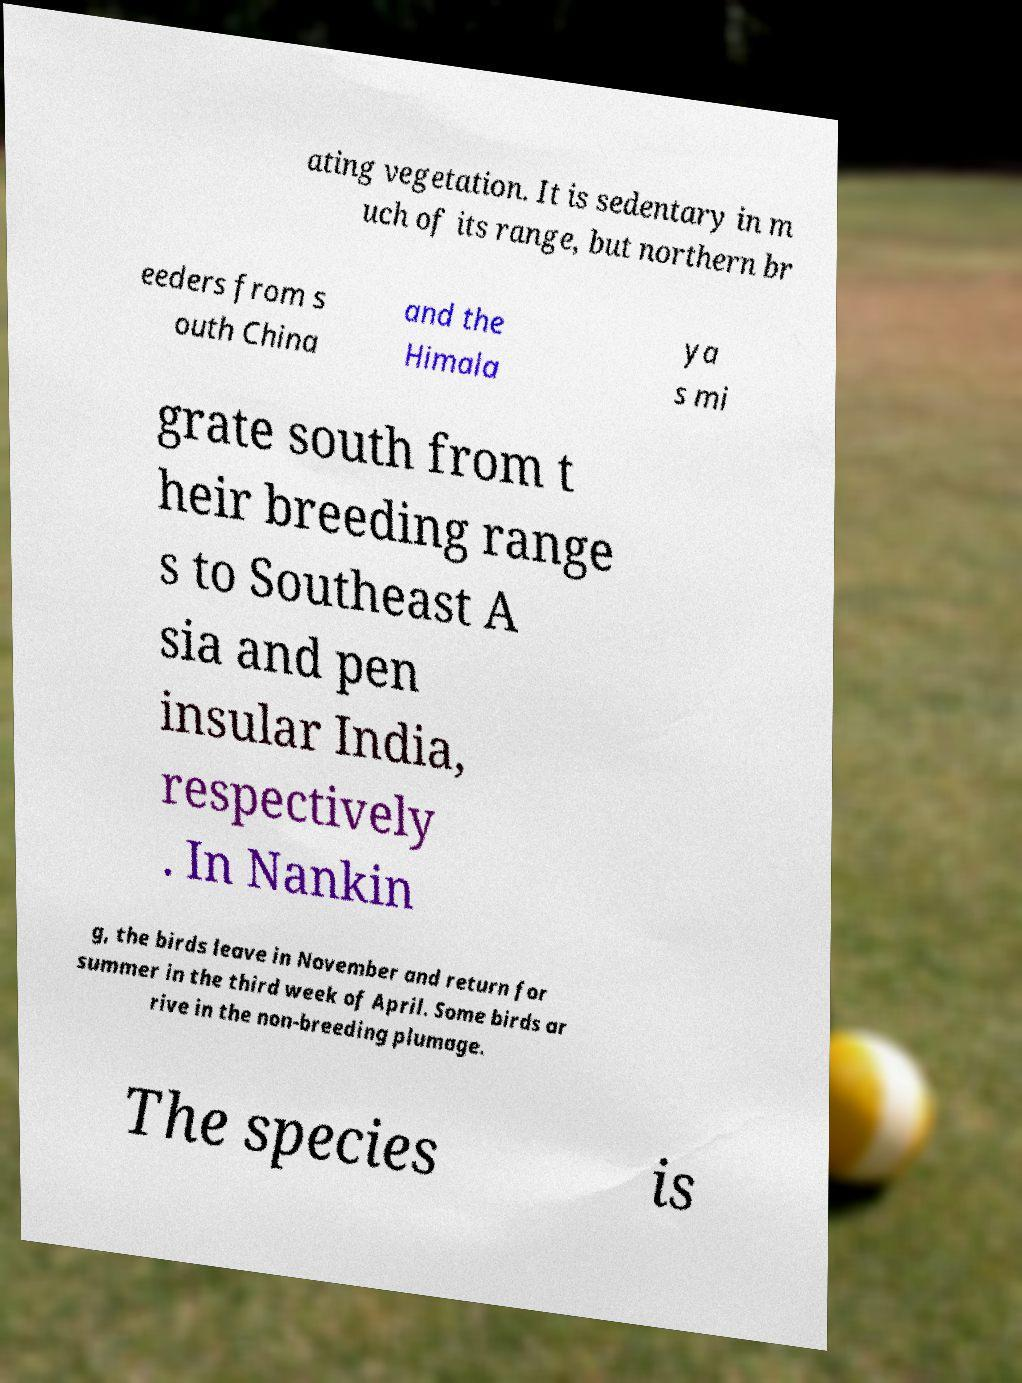Please read and relay the text visible in this image. What does it say? ating vegetation. It is sedentary in m uch of its range, but northern br eeders from s outh China and the Himala ya s mi grate south from t heir breeding range s to Southeast A sia and pen insular India, respectively . In Nankin g, the birds leave in November and return for summer in the third week of April. Some birds ar rive in the non-breeding plumage. The species is 